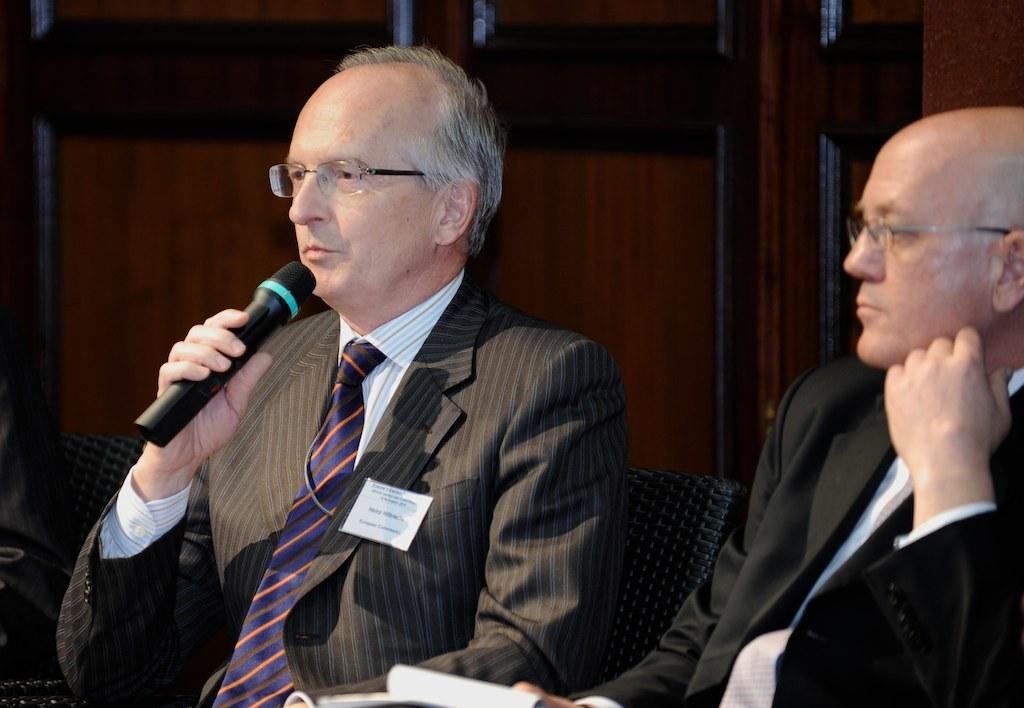Could you give a brief overview of what you see in this image? In this picture there are two men sitting in the chairs, wearing spectacles. One of the guy is holding a mic in his hand. In the background there is a wall. 